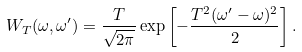Convert formula to latex. <formula><loc_0><loc_0><loc_500><loc_500>W _ { T } ( \omega , \omega ^ { \prime } ) = \frac { T } { \sqrt { 2 \pi } } \exp \left [ - \frac { T ^ { 2 } ( \omega ^ { \prime } - \omega ) ^ { 2 } } 2 \right ] .</formula> 